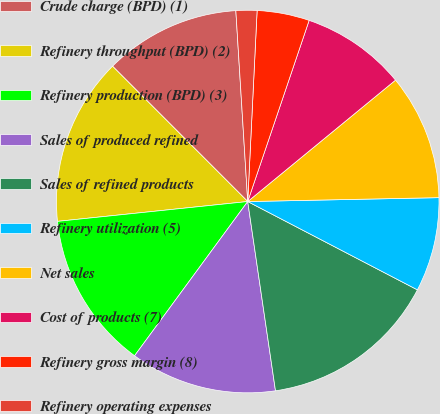Convert chart to OTSL. <chart><loc_0><loc_0><loc_500><loc_500><pie_chart><fcel>Crude charge (BPD) (1)<fcel>Refinery throughput (BPD) (2)<fcel>Refinery production (BPD) (3)<fcel>Sales of produced refined<fcel>Sales of refined products<fcel>Refinery utilization (5)<fcel>Net sales<fcel>Cost of products (7)<fcel>Refinery gross margin (8)<fcel>Refinery operating expenses<nl><fcel>11.5%<fcel>14.16%<fcel>13.27%<fcel>12.39%<fcel>15.04%<fcel>7.96%<fcel>10.62%<fcel>8.85%<fcel>4.42%<fcel>1.77%<nl></chart> 